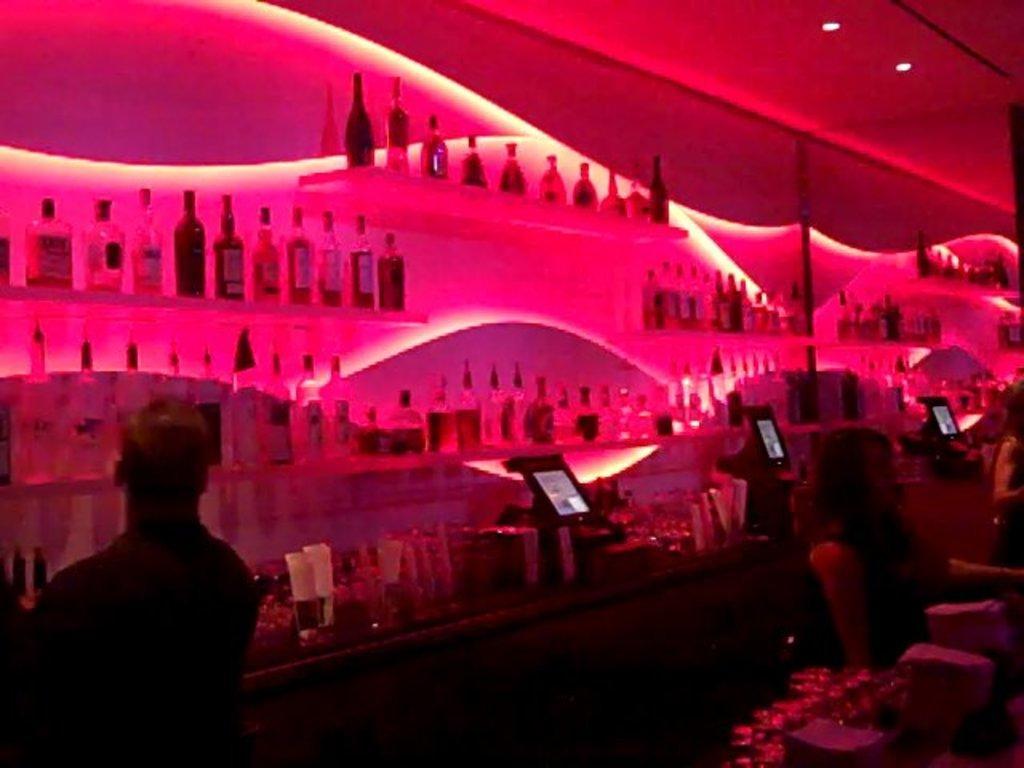Describe this image in one or two sentences. In this image I can see 3 persons in front and I can see tables on which there are electronic devices and other things. In the background I can see the racks on which there are number of bottles and on the top of this picture I can see the lights. 